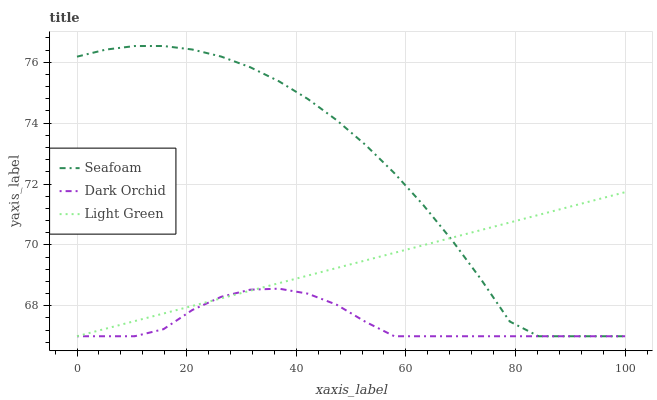Does Seafoam have the minimum area under the curve?
Answer yes or no. No. Does Dark Orchid have the maximum area under the curve?
Answer yes or no. No. Is Dark Orchid the smoothest?
Answer yes or no. No. Is Dark Orchid the roughest?
Answer yes or no. No. Does Dark Orchid have the highest value?
Answer yes or no. No. 